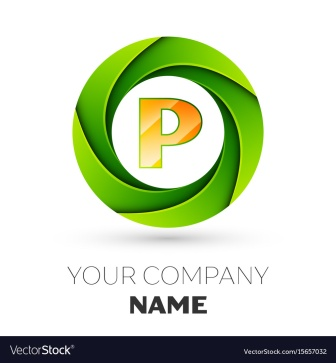What is this photo about? The image depicts a vibrant and modern logo design suited for youthful and dynamic companies, such as those in tech or creative industries. At the forefront is an elegant green circle encapsulating an orange letter 'P', tilted slightly to signify motion and progression. Below the emblem, the text 'YOUR COMPANY NAME' in black serves as a generic placeholder, inviting businesses to imagine their name in this stylish template. The bold color choice and sleek design suggest a brand identity that is fresh, innovative, and forward-thinking. 